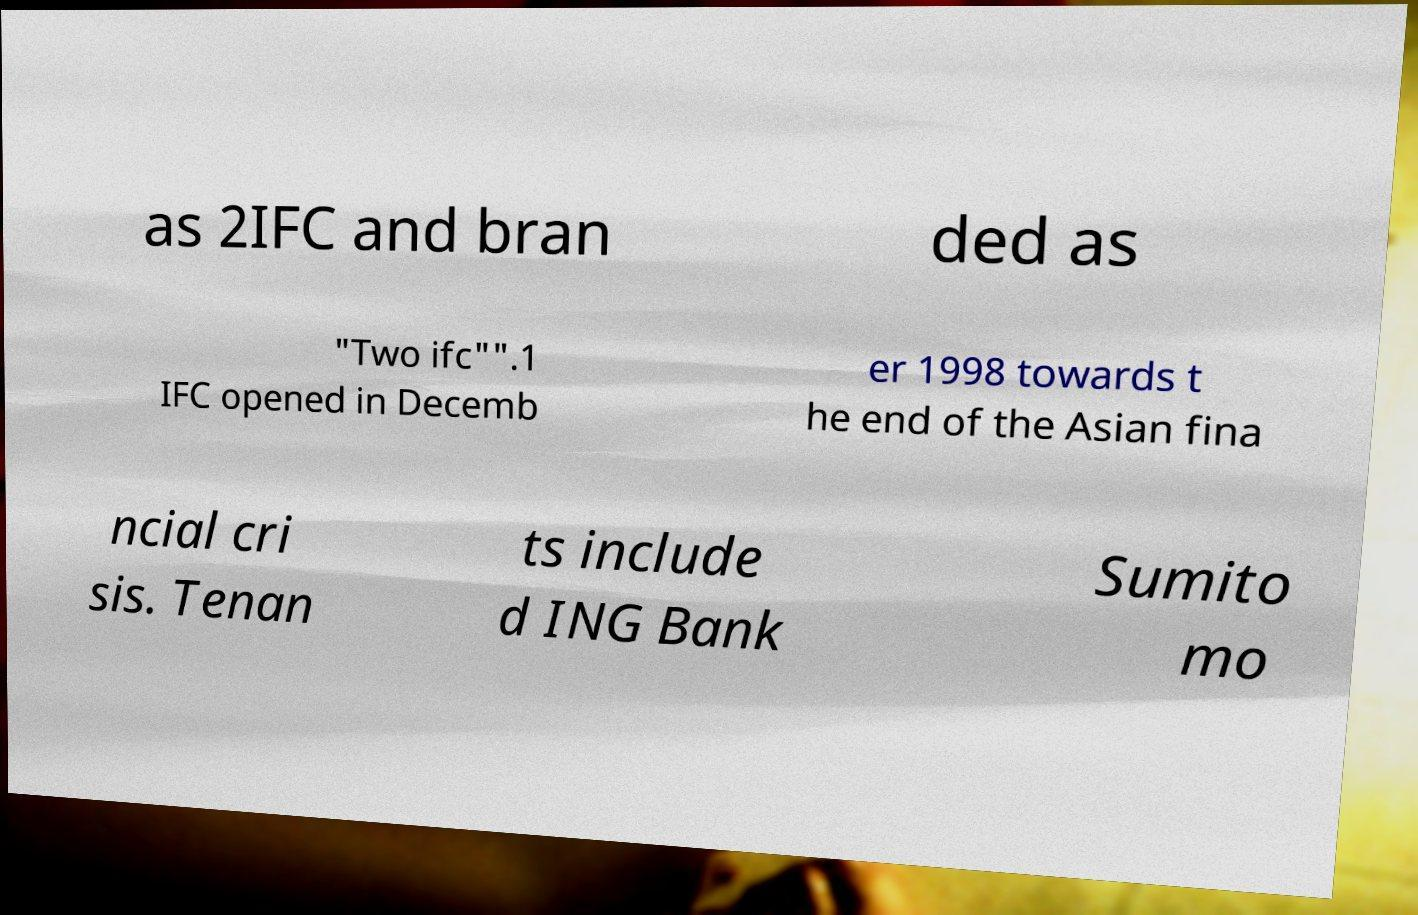Can you accurately transcribe the text from the provided image for me? as 2IFC and bran ded as "Two ifc"".1 IFC opened in Decemb er 1998 towards t he end of the Asian fina ncial cri sis. Tenan ts include d ING Bank Sumito mo 